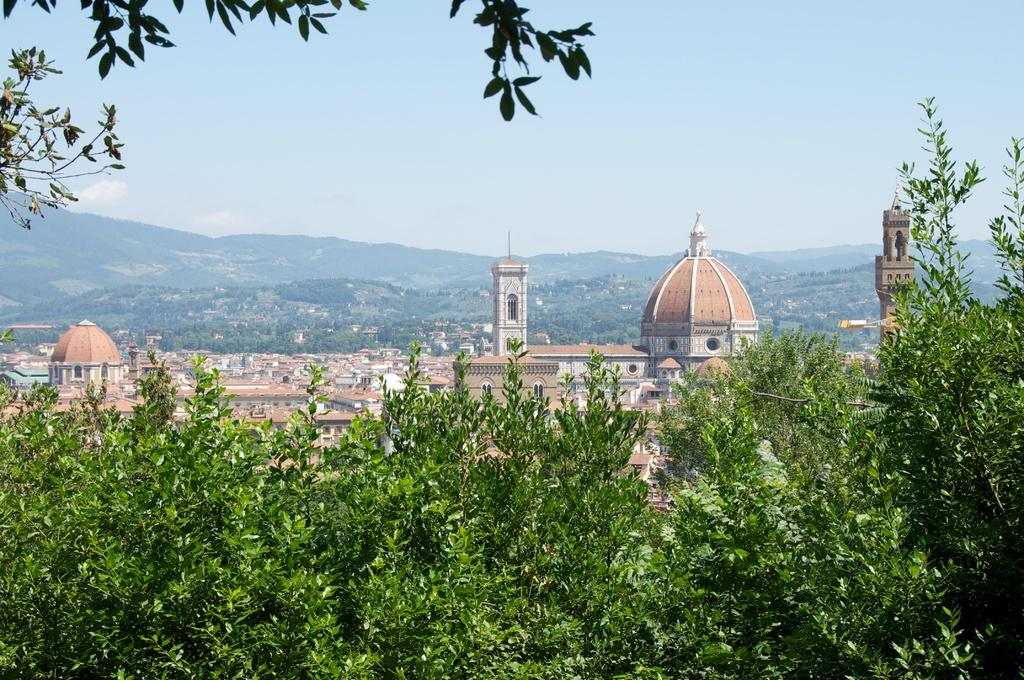What can be seen in the foreground of the image? In the foreground of the image, there are trees, mosques, minarets, towers, and cemeteries. What is visible in the background of the image? In the background of the image, there are mountains, houses, and the sky. Can you describe the time of day when the image was likely taken? The image was likely taken during the day, as the sky is visible and there is no indication of darkness. What caption is written on the image? There is no caption present on the image. Can you see any fairies flying around the trees in the image? There are no fairies present in the image; only trees, mosques, minarets, towers, cemeteries, mountains, houses, and the sky are visible. What type of toys can be seen in the image? There are no toys present in the image. 